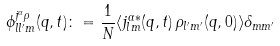Convert formula to latex. <formula><loc_0><loc_0><loc_500><loc_500>\phi ^ { j ^ { \alpha } \rho } _ { l l ^ { \prime } m } ( q , t ) \colon = \frac { 1 } { N } \langle j ^ { \alpha * } _ { l m } ( q , t ) \, \rho _ { l ^ { \prime } m ^ { \prime } } ( q , 0 ) \rangle \delta _ { m m ^ { \prime } }</formula> 